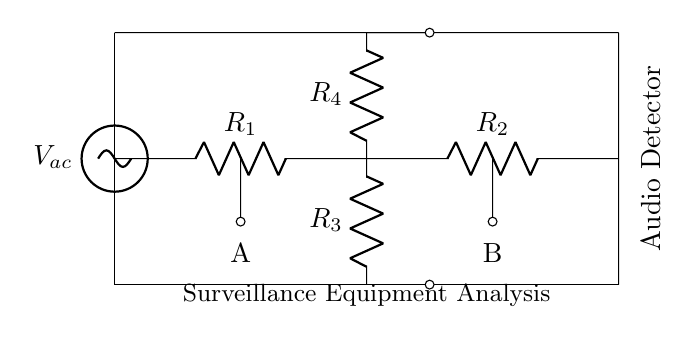What components are present in the circuit? The components of the circuit include resistors R1, R2, R3, and R4. They are connected in a specific arrangement.
Answer: Resistors R1, R2, R3, R4 What is the type of voltage source used in this circuit? The circuit includes a sinusoidal voltage source, which is typically used to generate alternating current.
Answer: Sinusoidal What does the label "A" represent in the circuit? The label "A" indicates one of the measurement points or terminals in the circuit where voltage is likely measured.
Answer: Measurement point A How many resistors are in series in this circuit? Four resistors appear to be arranged in series relative to the central node of the bridge; however, the arrangement should be analyzed in context. Here R2 and R4 are parallel to the main connecting wire, while R1 and R3 are in series with these parallel resistors.
Answer: Two What is the purpose of the audio detector in this AC bridge circuit? The audio detector's role is to analyze the audio frequency signals that are read through the bridge configuration, which helps in precise measurements of audio-related signals.
Answer: Analyze audio frequency signals What is the primary application realm indicated in this circuit diagram? The application realm indicated by the labeling in the circuit diagram is the analysis of surveillance equipment.
Answer: Surveillance Equipment Analysis How are R3 and R4 connected in this circuit? R3 and R4 are both connected to a common terminal, forming a part of the bridge. While they share a connection at the center, they are connected vertically, indicating a series arrangement of their drop relative to a common point.
Answer: In series 